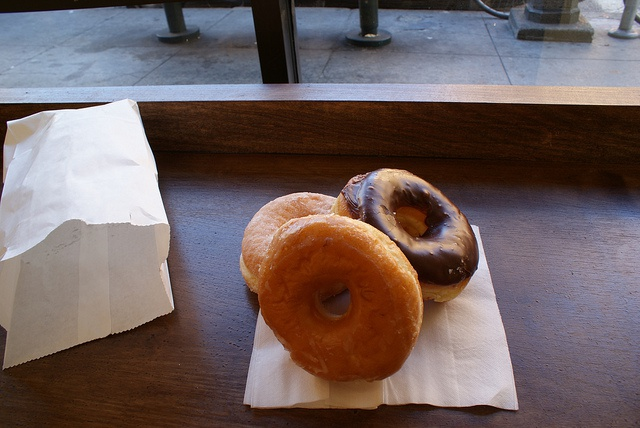Describe the objects in this image and their specific colors. I can see dining table in black, gray, and maroon tones, donut in black, maroon, brown, and tan tones, donut in black, maroon, darkgray, and gray tones, and donut in black, tan, brown, and salmon tones in this image. 